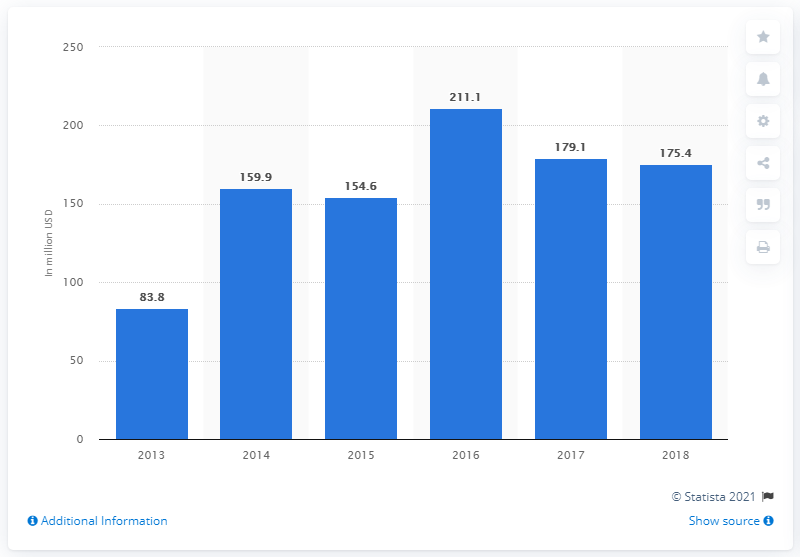What might have caused the dip in crowdfunding after 2016? The dip in reward-based crowdfunding after 2016 could be attributed to various factors such as market saturation, changes in consumer confidence, the emergence of new fundraising platforms, shifts in economic conditions, or evolving regulations around crowdfunding. While the chart does not specify reasons, it does indicate that the sector is dynamic and can be influenced by multiple external factors. Could the introduction of equity crowdfunding have an impact on these numbers? That's a plausible factor. Equity crowdfunding's rise in popularity offers investors a chance to own a stake in the ventures they fund, which could attract funds that might otherwise go into reward-based crowdfunding. This shift could indeed impact the overall transaction value in reward-based platforms as market preferences evolve. 